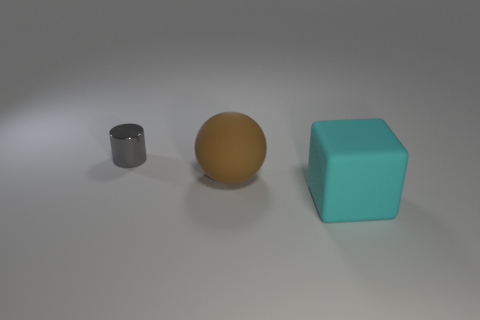How big is the matte object that is behind the large cyan matte block?
Provide a succinct answer. Large. What is the shape of the large rubber object left of the large rubber object in front of the large matte object that is on the left side of the big cube?
Give a very brief answer. Sphere. What number of other things are the same shape as the large cyan thing?
Give a very brief answer. 0. What number of shiny things are either small objects or small green cylinders?
Offer a terse response. 1. What is the material of the object that is to the left of the matte object left of the big cyan matte cube?
Your answer should be compact. Metal. Is the number of cyan rubber cubes that are behind the big ball greater than the number of brown matte things?
Offer a terse response. No. Is there a thing that has the same material as the small gray cylinder?
Ensure brevity in your answer.  No. Does the big object behind the large cyan matte block have the same shape as the large cyan rubber object?
Your answer should be very brief. No. How many large cyan cubes are to the left of the small gray cylinder on the left side of the big rubber thing that is behind the big block?
Make the answer very short. 0. Is the number of cylinders that are on the left side of the large brown matte sphere less than the number of large brown objects in front of the big rubber block?
Give a very brief answer. No. 